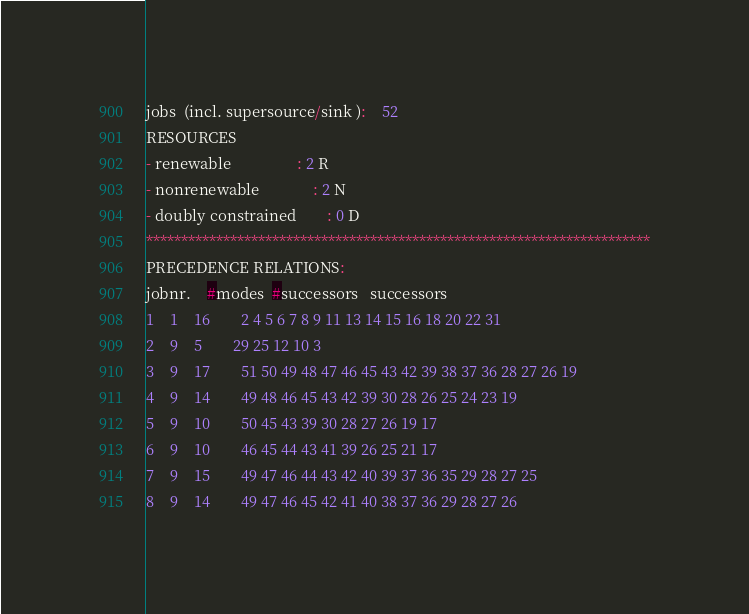Convert code to text. <code><loc_0><loc_0><loc_500><loc_500><_ObjectiveC_>jobs  (incl. supersource/sink ):	52
RESOURCES
- renewable                 : 2 R
- nonrenewable              : 2 N
- doubly constrained        : 0 D
************************************************************************
PRECEDENCE RELATIONS:
jobnr.    #modes  #successors   successors
1	1	16		2 4 5 6 7 8 9 11 13 14 15 16 18 20 22 31 
2	9	5		29 25 12 10 3 
3	9	17		51 50 49 48 47 46 45 43 42 39 38 37 36 28 27 26 19 
4	9	14		49 48 46 45 43 42 39 30 28 26 25 24 23 19 
5	9	10		50 45 43 39 30 28 27 26 19 17 
6	9	10		46 45 44 43 41 39 26 25 21 17 
7	9	15		49 47 46 44 43 42 40 39 37 36 35 29 28 27 25 
8	9	14		49 47 46 45 42 41 40 38 37 36 29 28 27 26 </code> 